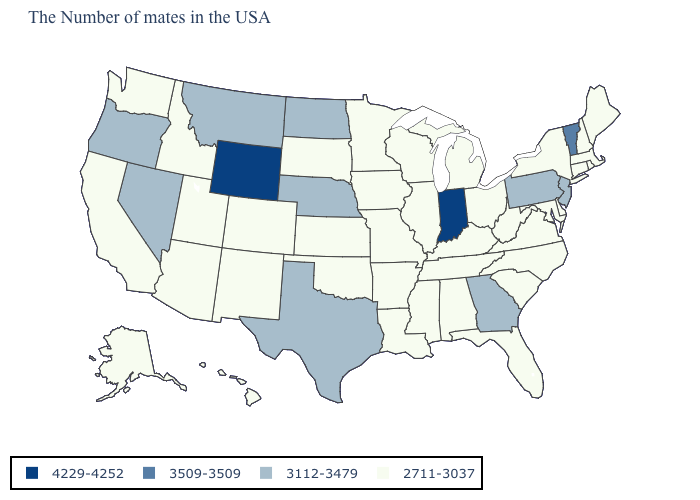Does New Jersey have the lowest value in the Northeast?
Quick response, please. No. What is the value of Nevada?
Keep it brief. 3112-3479. What is the value of Massachusetts?
Short answer required. 2711-3037. Name the states that have a value in the range 3112-3479?
Give a very brief answer. New Jersey, Pennsylvania, Georgia, Nebraska, Texas, North Dakota, Montana, Nevada, Oregon. Name the states that have a value in the range 4229-4252?
Short answer required. Indiana, Wyoming. Name the states that have a value in the range 3112-3479?
Keep it brief. New Jersey, Pennsylvania, Georgia, Nebraska, Texas, North Dakota, Montana, Nevada, Oregon. What is the highest value in the USA?
Write a very short answer. 4229-4252. Name the states that have a value in the range 4229-4252?
Short answer required. Indiana, Wyoming. What is the lowest value in states that border Texas?
Quick response, please. 2711-3037. Does Missouri have the same value as Montana?
Short answer required. No. Name the states that have a value in the range 3509-3509?
Short answer required. Vermont. What is the value of Virginia?
Short answer required. 2711-3037. 